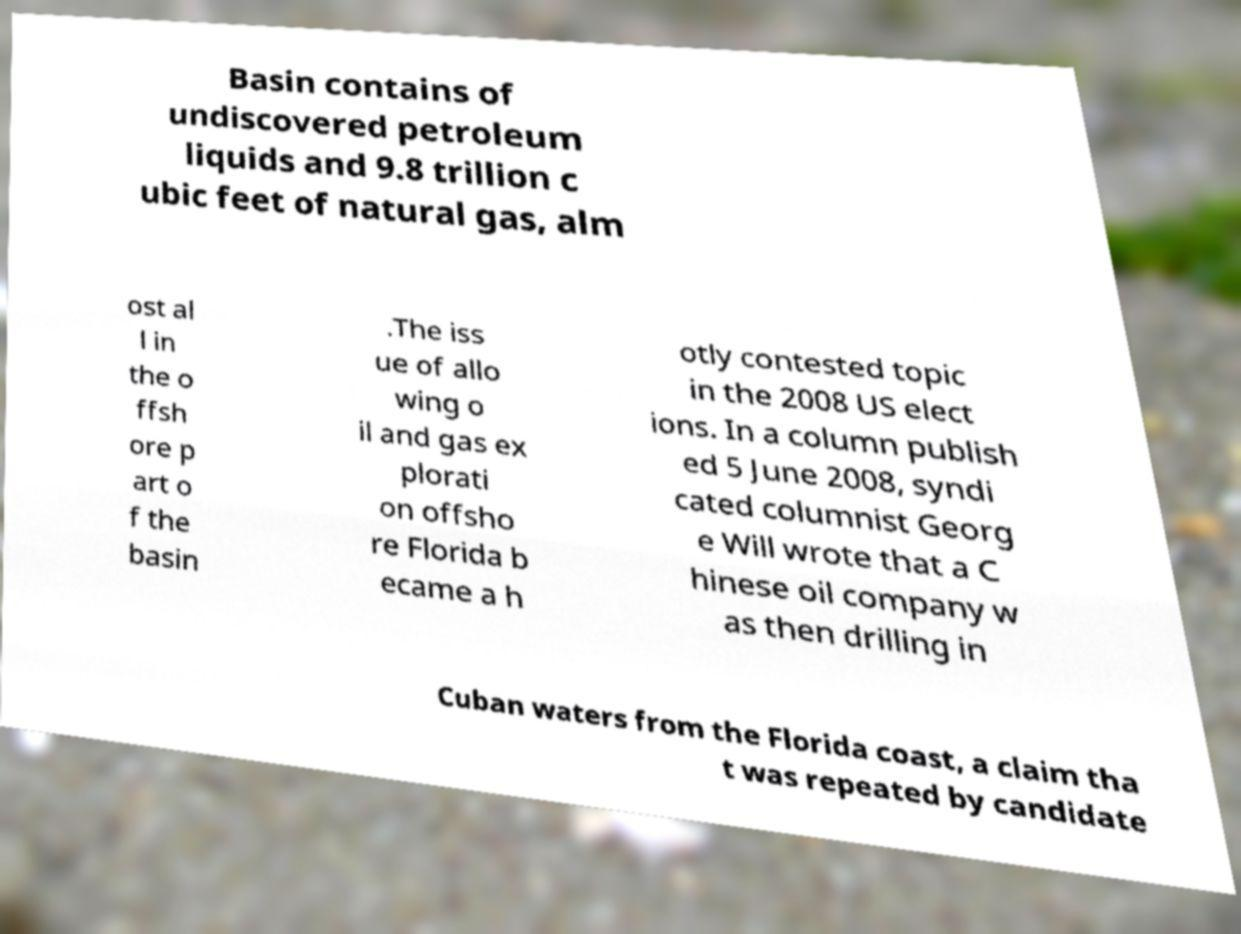Please read and relay the text visible in this image. What does it say? Basin contains of undiscovered petroleum liquids and 9.8 trillion c ubic feet of natural gas, alm ost al l in the o ffsh ore p art o f the basin .The iss ue of allo wing o il and gas ex plorati on offsho re Florida b ecame a h otly contested topic in the 2008 US elect ions. In a column publish ed 5 June 2008, syndi cated columnist Georg e Will wrote that a C hinese oil company w as then drilling in Cuban waters from the Florida coast, a claim tha t was repeated by candidate 